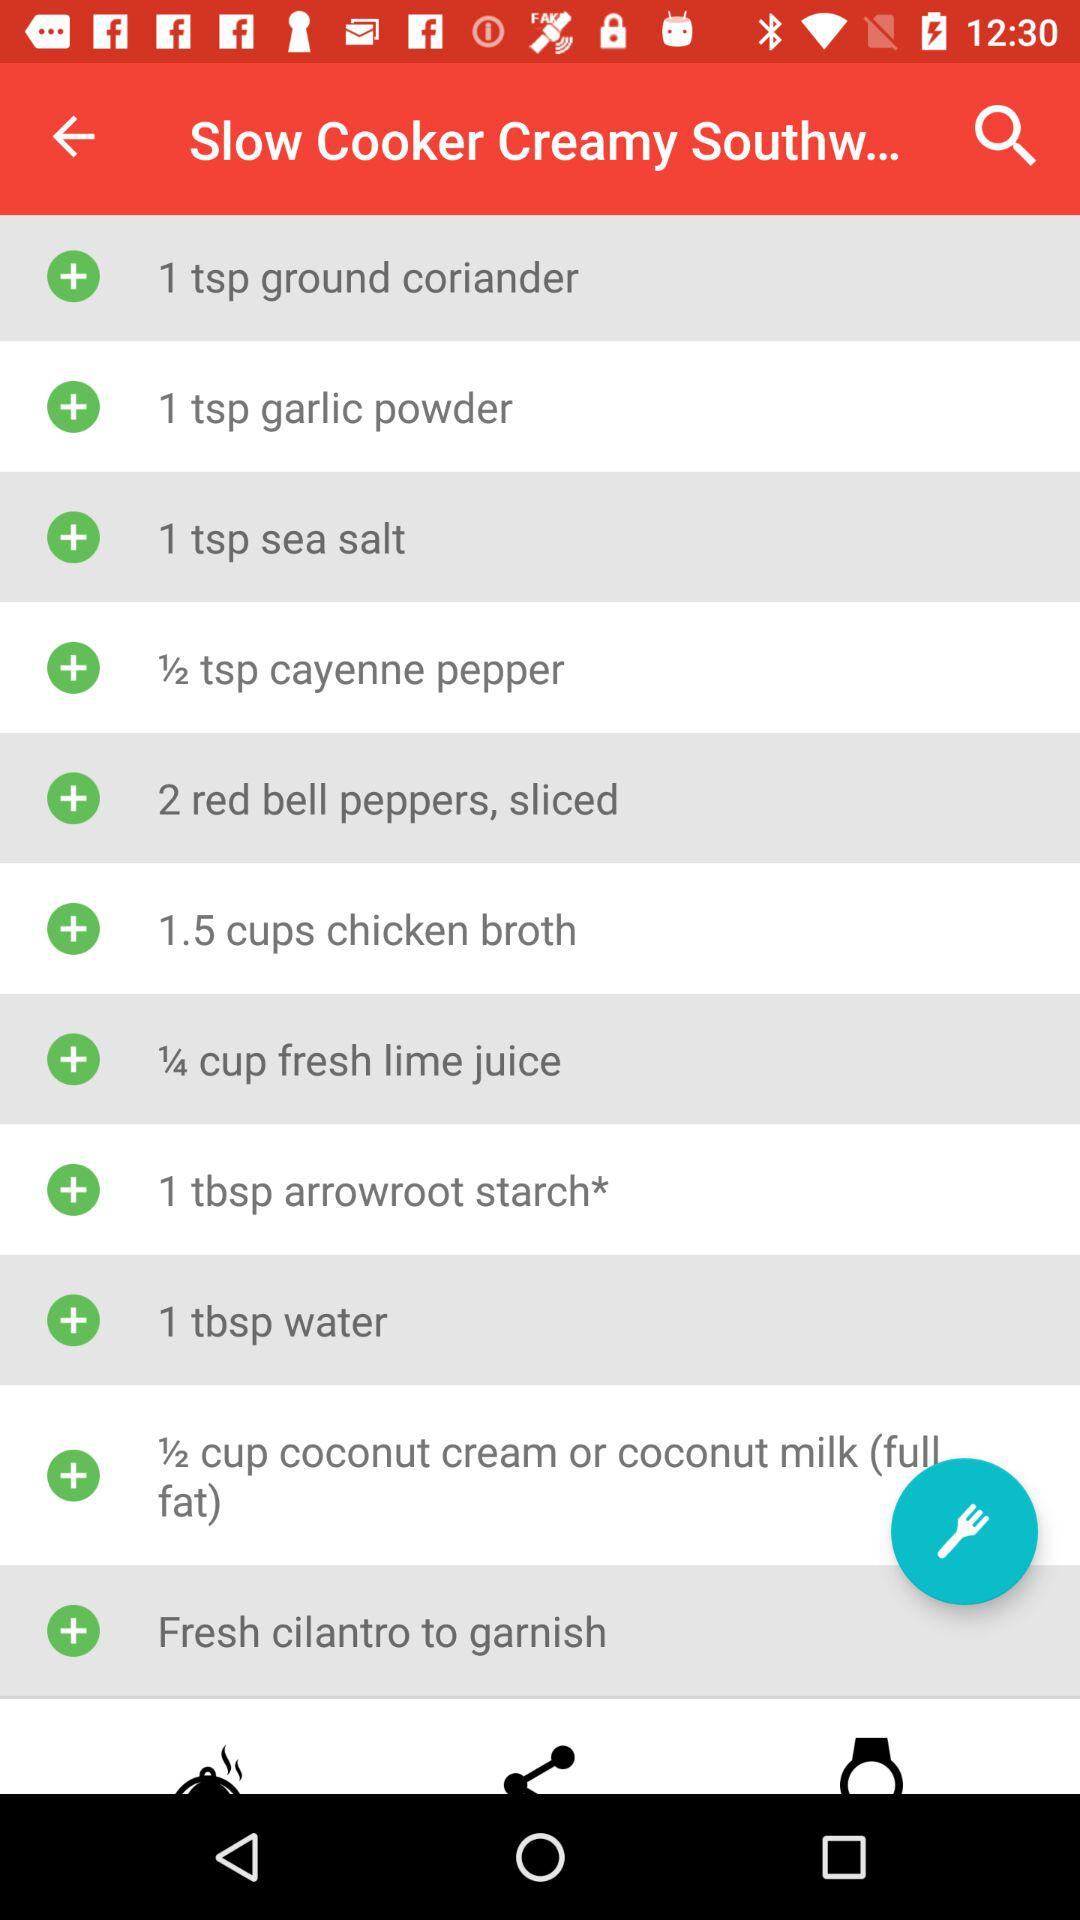How many tablespoons of sea salt are needed? There is 1 tablespoon of sea salt needed. 